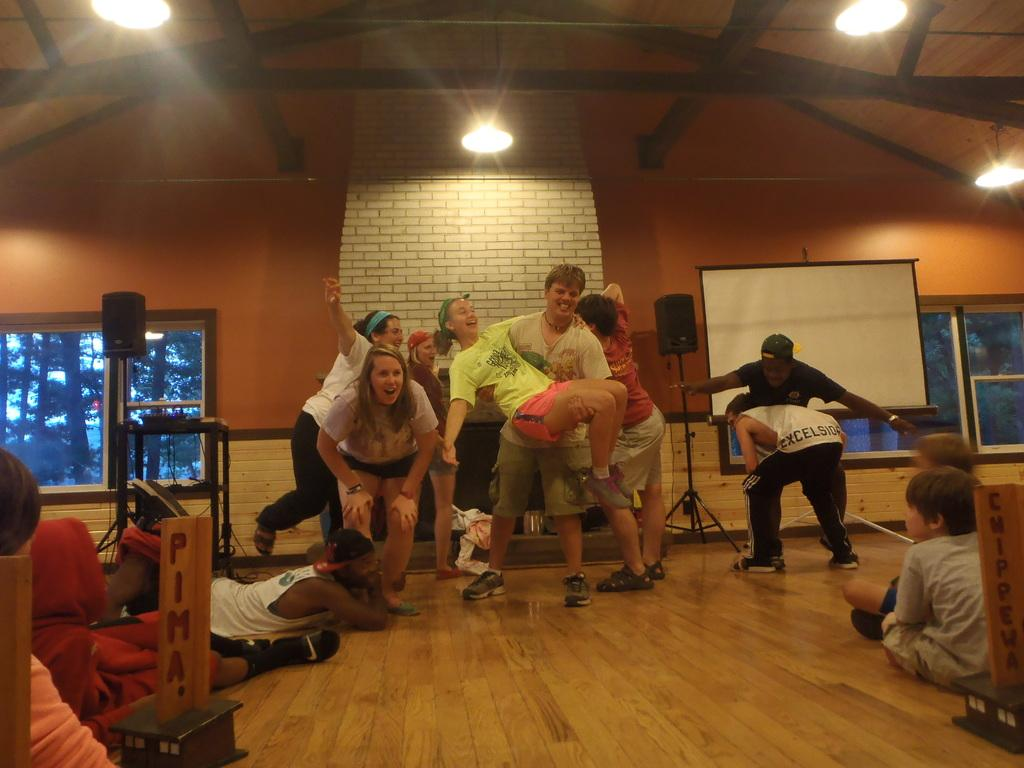<image>
Present a compact description of the photo's key features. A group of people perform for a group of children, one has excelsior on his T-shirt. 